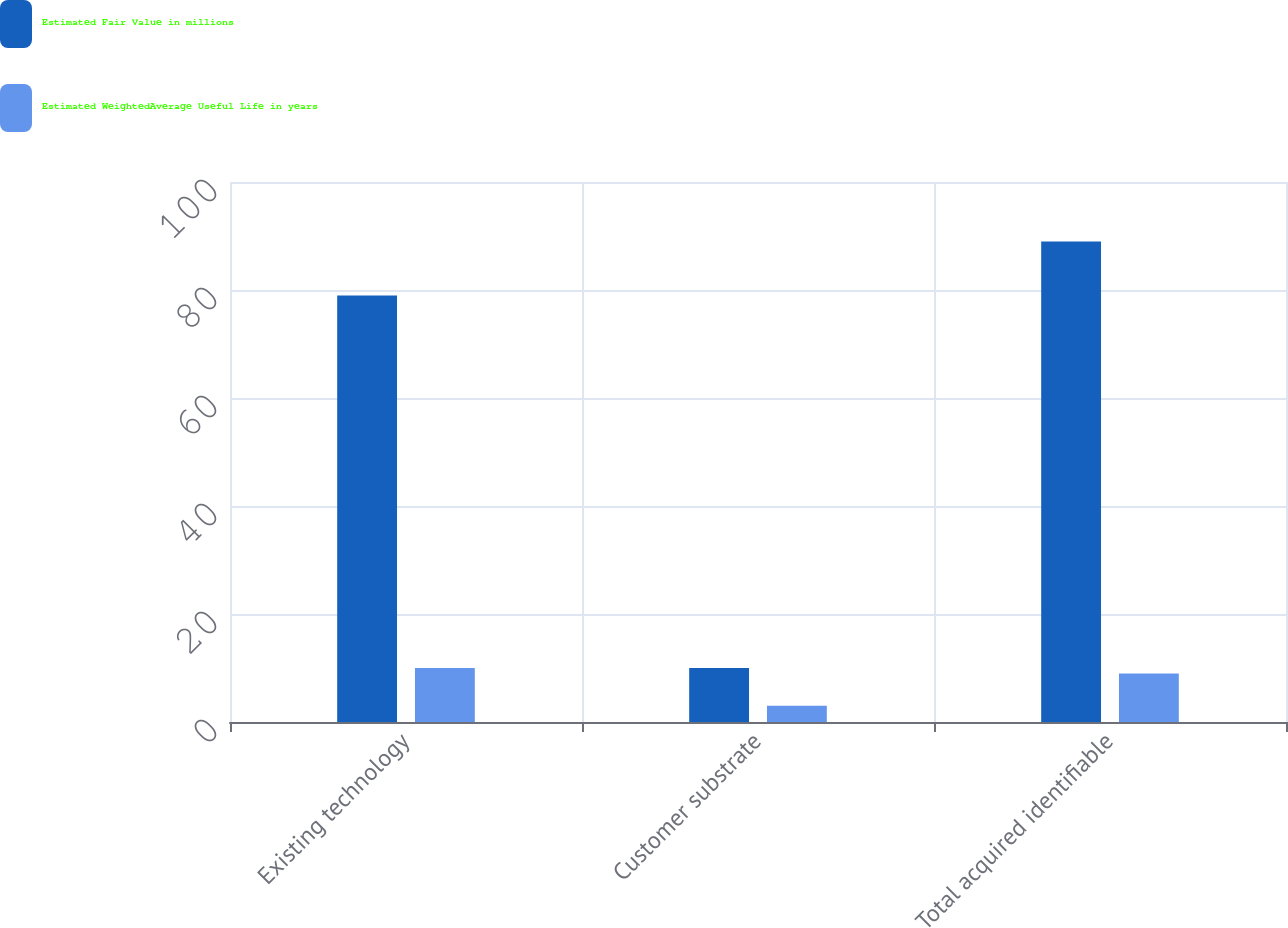Convert chart. <chart><loc_0><loc_0><loc_500><loc_500><stacked_bar_chart><ecel><fcel>Existing technology<fcel>Customer substrate<fcel>Total acquired identifiable<nl><fcel>Estimated Fair Value in millions<fcel>79<fcel>10<fcel>89<nl><fcel>Estimated WeightedAverage Useful Life in years<fcel>10<fcel>3<fcel>9<nl></chart> 